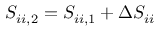<formula> <loc_0><loc_0><loc_500><loc_500>S _ { i i , 2 } = S _ { i i , 1 } + \Delta S _ { i i }</formula> 